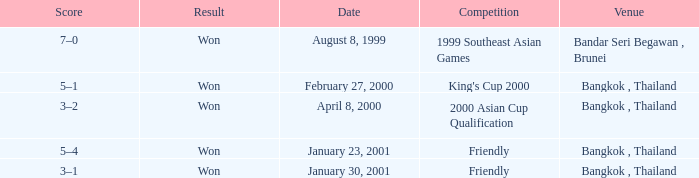What was the result from the 2000 asian cup qualification? Won. 